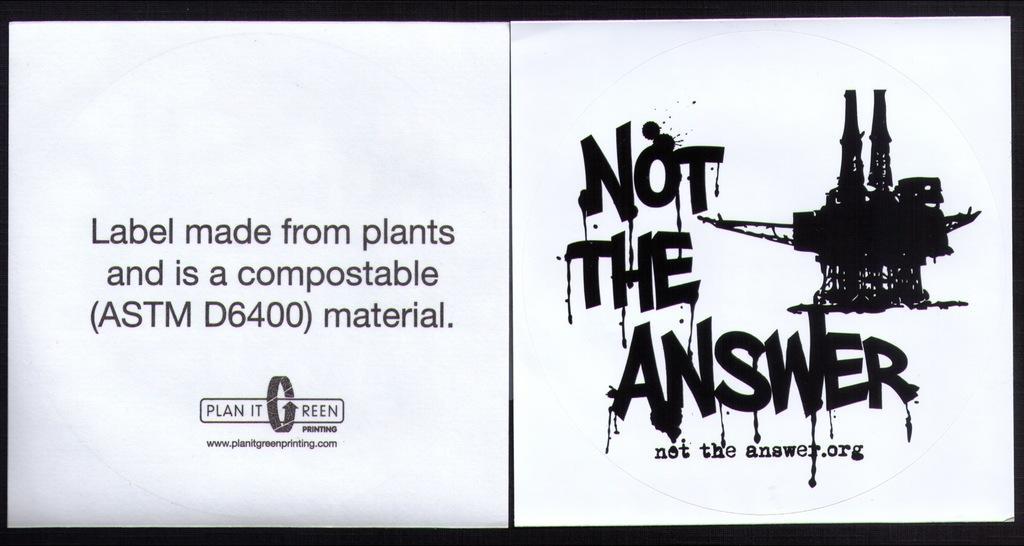Describe this image in one or two sentences. This looks like a collage picture. These are the letters. I think this is the drawing which is black in color. 